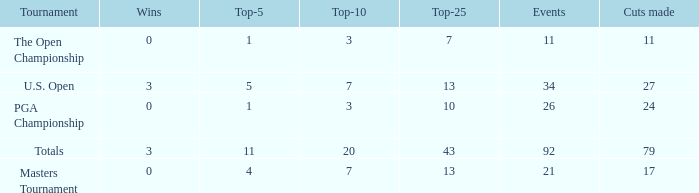Name the total number of wins with top-25 of 10 and events less than 26 0.0. 